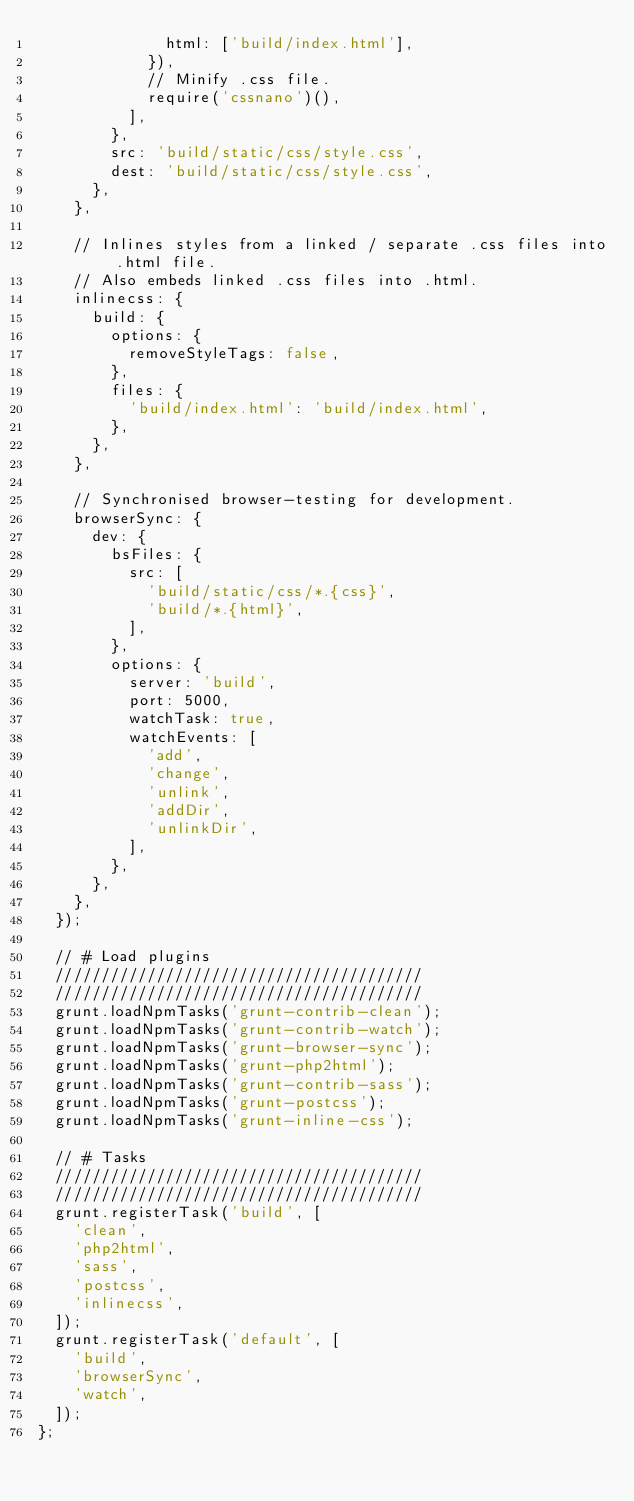Convert code to text. <code><loc_0><loc_0><loc_500><loc_500><_JavaScript_>              html: ['build/index.html'],
            }),
            // Minify .css file.
            require('cssnano')(),
          ],
        },
        src: 'build/static/css/style.css',
        dest: 'build/static/css/style.css',
      },
    },

    // Inlines styles from a linked / separate .css files into .html file.
    // Also embeds linked .css files into .html.
    inlinecss: {
      build: {
        options: {
          removeStyleTags: false,
        },
        files: {
          'build/index.html': 'build/index.html',
        },
      },
    },

    // Synchronised browser-testing for development.
    browserSync: {
      dev: {
        bsFiles: {
          src: [
            'build/static/css/*.{css}',
            'build/*.{html}',
          ],
        },
        options: {
          server: 'build',
          port: 5000,
          watchTask: true,
          watchEvents: [
            'add',
            'change',
            'unlink',
            'addDir',
            'unlinkDir',
          ],
        },
      },
    },
  });

  // # Load plugins
  ////////////////////////////////////////
  ////////////////////////////////////////
  grunt.loadNpmTasks('grunt-contrib-clean');
  grunt.loadNpmTasks('grunt-contrib-watch');
  grunt.loadNpmTasks('grunt-browser-sync');
  grunt.loadNpmTasks('grunt-php2html');
  grunt.loadNpmTasks('grunt-contrib-sass');
  grunt.loadNpmTasks('grunt-postcss');
  grunt.loadNpmTasks('grunt-inline-css');

  // # Tasks
  ////////////////////////////////////////
  ////////////////////////////////////////
  grunt.registerTask('build', [
    'clean',
    'php2html',
    'sass',
    'postcss',
    'inlinecss',
  ]);
  grunt.registerTask('default', [
    'build',
    'browserSync',
    'watch',
  ]);
};
</code> 